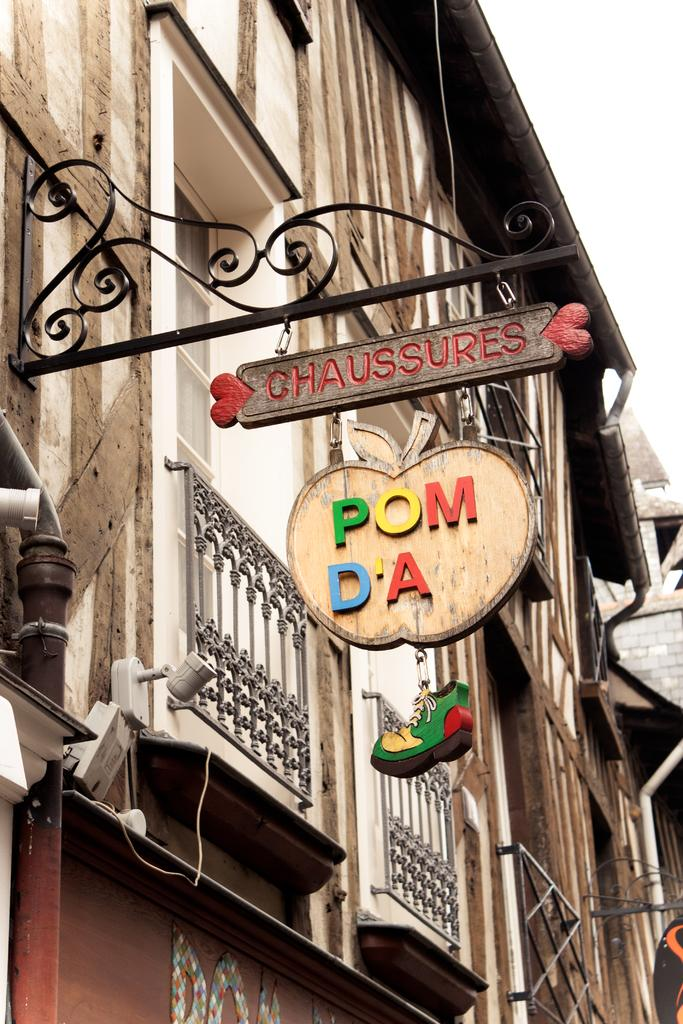Provide a one-sentence caption for the provided image. A building displays a sign that says chaussures in red paint on the top. 